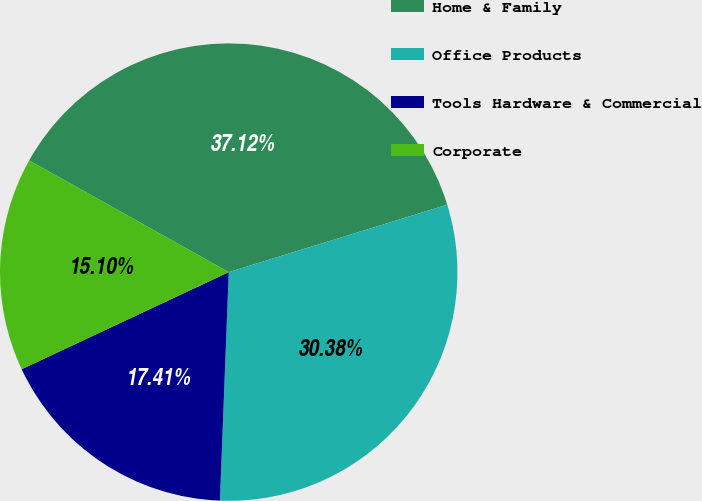Convert chart. <chart><loc_0><loc_0><loc_500><loc_500><pie_chart><fcel>Home & Family<fcel>Office Products<fcel>Tools Hardware & Commercial<fcel>Corporate<nl><fcel>37.12%<fcel>30.38%<fcel>17.41%<fcel>15.1%<nl></chart> 